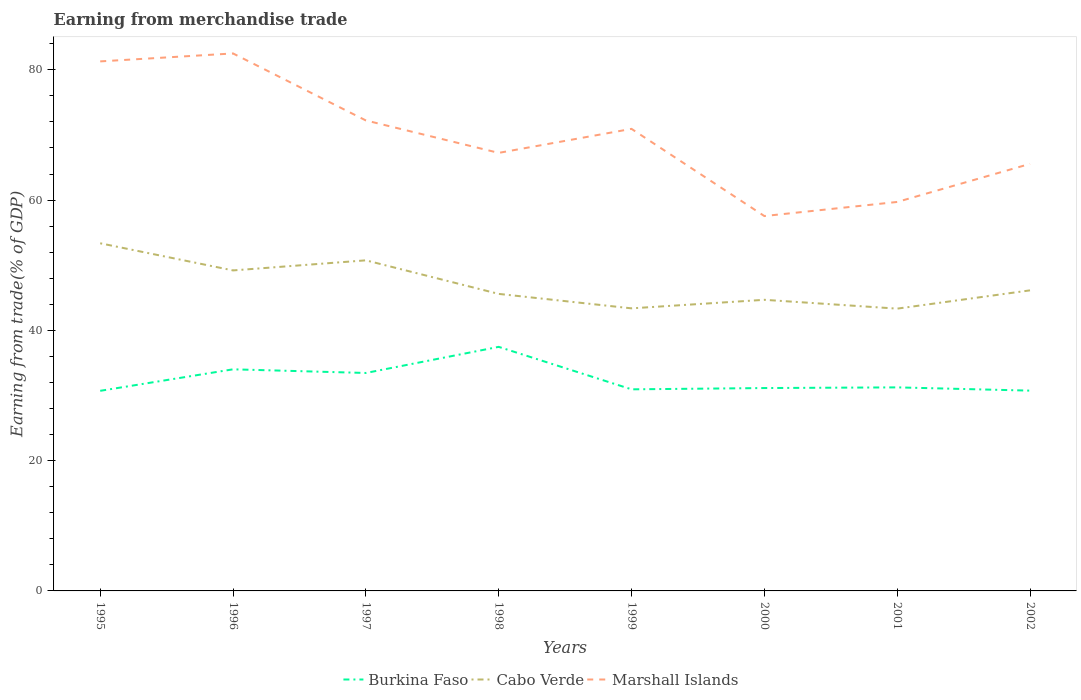Is the number of lines equal to the number of legend labels?
Your response must be concise. Yes. Across all years, what is the maximum earnings from trade in Cabo Verde?
Offer a very short reply. 43.34. In which year was the earnings from trade in Cabo Verde maximum?
Keep it short and to the point. 2001. What is the total earnings from trade in Marshall Islands in the graph?
Keep it short and to the point. 10.29. What is the difference between the highest and the second highest earnings from trade in Cabo Verde?
Your response must be concise. 10.03. What is the difference between the highest and the lowest earnings from trade in Marshall Islands?
Your answer should be compact. 4. Does the graph contain grids?
Ensure brevity in your answer.  No. Where does the legend appear in the graph?
Your answer should be very brief. Bottom center. How are the legend labels stacked?
Provide a succinct answer. Horizontal. What is the title of the graph?
Offer a terse response. Earning from merchandise trade. Does "Kyrgyz Republic" appear as one of the legend labels in the graph?
Your answer should be very brief. No. What is the label or title of the Y-axis?
Offer a terse response. Earning from trade(% of GDP). What is the Earning from trade(% of GDP) of Burkina Faso in 1995?
Keep it short and to the point. 30.72. What is the Earning from trade(% of GDP) in Cabo Verde in 1995?
Give a very brief answer. 53.37. What is the Earning from trade(% of GDP) in Marshall Islands in 1995?
Give a very brief answer. 81.3. What is the Earning from trade(% of GDP) in Burkina Faso in 1996?
Your answer should be very brief. 34.02. What is the Earning from trade(% of GDP) of Cabo Verde in 1996?
Make the answer very short. 49.21. What is the Earning from trade(% of GDP) in Marshall Islands in 1996?
Keep it short and to the point. 82.52. What is the Earning from trade(% of GDP) of Burkina Faso in 1997?
Offer a very short reply. 33.46. What is the Earning from trade(% of GDP) of Cabo Verde in 1997?
Give a very brief answer. 50.75. What is the Earning from trade(% of GDP) in Marshall Islands in 1997?
Provide a succinct answer. 72.23. What is the Earning from trade(% of GDP) in Burkina Faso in 1998?
Offer a very short reply. 37.47. What is the Earning from trade(% of GDP) of Cabo Verde in 1998?
Provide a short and direct response. 45.6. What is the Earning from trade(% of GDP) of Marshall Islands in 1998?
Keep it short and to the point. 67.25. What is the Earning from trade(% of GDP) of Burkina Faso in 1999?
Give a very brief answer. 30.95. What is the Earning from trade(% of GDP) of Cabo Verde in 1999?
Give a very brief answer. 43.38. What is the Earning from trade(% of GDP) of Marshall Islands in 1999?
Provide a succinct answer. 70.94. What is the Earning from trade(% of GDP) in Burkina Faso in 2000?
Give a very brief answer. 31.15. What is the Earning from trade(% of GDP) of Cabo Verde in 2000?
Ensure brevity in your answer.  44.69. What is the Earning from trade(% of GDP) of Marshall Islands in 2000?
Your answer should be compact. 57.55. What is the Earning from trade(% of GDP) in Burkina Faso in 2001?
Keep it short and to the point. 31.25. What is the Earning from trade(% of GDP) in Cabo Verde in 2001?
Ensure brevity in your answer.  43.34. What is the Earning from trade(% of GDP) of Marshall Islands in 2001?
Keep it short and to the point. 59.72. What is the Earning from trade(% of GDP) of Burkina Faso in 2002?
Provide a succinct answer. 30.75. What is the Earning from trade(% of GDP) of Cabo Verde in 2002?
Give a very brief answer. 46.14. What is the Earning from trade(% of GDP) in Marshall Islands in 2002?
Keep it short and to the point. 65.56. Across all years, what is the maximum Earning from trade(% of GDP) of Burkina Faso?
Make the answer very short. 37.47. Across all years, what is the maximum Earning from trade(% of GDP) of Cabo Verde?
Keep it short and to the point. 53.37. Across all years, what is the maximum Earning from trade(% of GDP) of Marshall Islands?
Your answer should be very brief. 82.52. Across all years, what is the minimum Earning from trade(% of GDP) of Burkina Faso?
Keep it short and to the point. 30.72. Across all years, what is the minimum Earning from trade(% of GDP) in Cabo Verde?
Make the answer very short. 43.34. Across all years, what is the minimum Earning from trade(% of GDP) in Marshall Islands?
Offer a very short reply. 57.55. What is the total Earning from trade(% of GDP) in Burkina Faso in the graph?
Keep it short and to the point. 259.77. What is the total Earning from trade(% of GDP) of Cabo Verde in the graph?
Your response must be concise. 376.49. What is the total Earning from trade(% of GDP) in Marshall Islands in the graph?
Offer a very short reply. 557.06. What is the difference between the Earning from trade(% of GDP) in Burkina Faso in 1995 and that in 1996?
Offer a very short reply. -3.3. What is the difference between the Earning from trade(% of GDP) in Cabo Verde in 1995 and that in 1996?
Ensure brevity in your answer.  4.17. What is the difference between the Earning from trade(% of GDP) in Marshall Islands in 1995 and that in 1996?
Your answer should be very brief. -1.22. What is the difference between the Earning from trade(% of GDP) of Burkina Faso in 1995 and that in 1997?
Your answer should be very brief. -2.74. What is the difference between the Earning from trade(% of GDP) of Cabo Verde in 1995 and that in 1997?
Offer a terse response. 2.62. What is the difference between the Earning from trade(% of GDP) of Marshall Islands in 1995 and that in 1997?
Offer a very short reply. 9.07. What is the difference between the Earning from trade(% of GDP) of Burkina Faso in 1995 and that in 1998?
Offer a terse response. -6.75. What is the difference between the Earning from trade(% of GDP) of Cabo Verde in 1995 and that in 1998?
Offer a very short reply. 7.77. What is the difference between the Earning from trade(% of GDP) in Marshall Islands in 1995 and that in 1998?
Give a very brief answer. 14.05. What is the difference between the Earning from trade(% of GDP) of Burkina Faso in 1995 and that in 1999?
Provide a succinct answer. -0.23. What is the difference between the Earning from trade(% of GDP) in Cabo Verde in 1995 and that in 1999?
Provide a short and direct response. 9.99. What is the difference between the Earning from trade(% of GDP) of Marshall Islands in 1995 and that in 1999?
Ensure brevity in your answer.  10.36. What is the difference between the Earning from trade(% of GDP) in Burkina Faso in 1995 and that in 2000?
Offer a very short reply. -0.43. What is the difference between the Earning from trade(% of GDP) of Cabo Verde in 1995 and that in 2000?
Provide a succinct answer. 8.68. What is the difference between the Earning from trade(% of GDP) in Marshall Islands in 1995 and that in 2000?
Your response must be concise. 23.74. What is the difference between the Earning from trade(% of GDP) in Burkina Faso in 1995 and that in 2001?
Your answer should be very brief. -0.53. What is the difference between the Earning from trade(% of GDP) of Cabo Verde in 1995 and that in 2001?
Your answer should be compact. 10.03. What is the difference between the Earning from trade(% of GDP) of Marshall Islands in 1995 and that in 2001?
Offer a very short reply. 21.58. What is the difference between the Earning from trade(% of GDP) of Burkina Faso in 1995 and that in 2002?
Offer a terse response. -0.03. What is the difference between the Earning from trade(% of GDP) in Cabo Verde in 1995 and that in 2002?
Give a very brief answer. 7.23. What is the difference between the Earning from trade(% of GDP) in Marshall Islands in 1995 and that in 2002?
Offer a terse response. 15.73. What is the difference between the Earning from trade(% of GDP) in Burkina Faso in 1996 and that in 1997?
Offer a very short reply. 0.56. What is the difference between the Earning from trade(% of GDP) of Cabo Verde in 1996 and that in 1997?
Your answer should be compact. -1.55. What is the difference between the Earning from trade(% of GDP) of Marshall Islands in 1996 and that in 1997?
Your answer should be very brief. 10.29. What is the difference between the Earning from trade(% of GDP) of Burkina Faso in 1996 and that in 1998?
Your answer should be very brief. -3.45. What is the difference between the Earning from trade(% of GDP) of Cabo Verde in 1996 and that in 1998?
Your answer should be compact. 3.6. What is the difference between the Earning from trade(% of GDP) in Marshall Islands in 1996 and that in 1998?
Make the answer very short. 15.27. What is the difference between the Earning from trade(% of GDP) of Burkina Faso in 1996 and that in 1999?
Ensure brevity in your answer.  3.07. What is the difference between the Earning from trade(% of GDP) of Cabo Verde in 1996 and that in 1999?
Your answer should be compact. 5.82. What is the difference between the Earning from trade(% of GDP) of Marshall Islands in 1996 and that in 1999?
Ensure brevity in your answer.  11.58. What is the difference between the Earning from trade(% of GDP) of Burkina Faso in 1996 and that in 2000?
Give a very brief answer. 2.88. What is the difference between the Earning from trade(% of GDP) of Cabo Verde in 1996 and that in 2000?
Provide a short and direct response. 4.51. What is the difference between the Earning from trade(% of GDP) of Marshall Islands in 1996 and that in 2000?
Offer a very short reply. 24.96. What is the difference between the Earning from trade(% of GDP) in Burkina Faso in 1996 and that in 2001?
Give a very brief answer. 2.77. What is the difference between the Earning from trade(% of GDP) of Cabo Verde in 1996 and that in 2001?
Ensure brevity in your answer.  5.87. What is the difference between the Earning from trade(% of GDP) of Marshall Islands in 1996 and that in 2001?
Offer a very short reply. 22.8. What is the difference between the Earning from trade(% of GDP) of Burkina Faso in 1996 and that in 2002?
Offer a terse response. 3.27. What is the difference between the Earning from trade(% of GDP) of Cabo Verde in 1996 and that in 2002?
Offer a very short reply. 3.06. What is the difference between the Earning from trade(% of GDP) of Marshall Islands in 1996 and that in 2002?
Give a very brief answer. 16.95. What is the difference between the Earning from trade(% of GDP) in Burkina Faso in 1997 and that in 1998?
Keep it short and to the point. -4.01. What is the difference between the Earning from trade(% of GDP) of Cabo Verde in 1997 and that in 1998?
Your answer should be compact. 5.15. What is the difference between the Earning from trade(% of GDP) in Marshall Islands in 1997 and that in 1998?
Make the answer very short. 4.98. What is the difference between the Earning from trade(% of GDP) in Burkina Faso in 1997 and that in 1999?
Make the answer very short. 2.51. What is the difference between the Earning from trade(% of GDP) in Cabo Verde in 1997 and that in 1999?
Give a very brief answer. 7.37. What is the difference between the Earning from trade(% of GDP) of Marshall Islands in 1997 and that in 1999?
Offer a terse response. 1.29. What is the difference between the Earning from trade(% of GDP) of Burkina Faso in 1997 and that in 2000?
Make the answer very short. 2.31. What is the difference between the Earning from trade(% of GDP) of Cabo Verde in 1997 and that in 2000?
Keep it short and to the point. 6.06. What is the difference between the Earning from trade(% of GDP) in Marshall Islands in 1997 and that in 2000?
Your answer should be very brief. 14.68. What is the difference between the Earning from trade(% of GDP) in Burkina Faso in 1997 and that in 2001?
Keep it short and to the point. 2.21. What is the difference between the Earning from trade(% of GDP) in Cabo Verde in 1997 and that in 2001?
Your answer should be very brief. 7.42. What is the difference between the Earning from trade(% of GDP) in Marshall Islands in 1997 and that in 2001?
Offer a very short reply. 12.51. What is the difference between the Earning from trade(% of GDP) of Burkina Faso in 1997 and that in 2002?
Offer a terse response. 2.71. What is the difference between the Earning from trade(% of GDP) in Cabo Verde in 1997 and that in 2002?
Your answer should be very brief. 4.61. What is the difference between the Earning from trade(% of GDP) in Marshall Islands in 1997 and that in 2002?
Offer a very short reply. 6.66. What is the difference between the Earning from trade(% of GDP) in Burkina Faso in 1998 and that in 1999?
Your answer should be very brief. 6.52. What is the difference between the Earning from trade(% of GDP) in Cabo Verde in 1998 and that in 1999?
Your answer should be very brief. 2.22. What is the difference between the Earning from trade(% of GDP) of Marshall Islands in 1998 and that in 1999?
Keep it short and to the point. -3.69. What is the difference between the Earning from trade(% of GDP) in Burkina Faso in 1998 and that in 2000?
Your response must be concise. 6.32. What is the difference between the Earning from trade(% of GDP) in Cabo Verde in 1998 and that in 2000?
Ensure brevity in your answer.  0.91. What is the difference between the Earning from trade(% of GDP) in Marshall Islands in 1998 and that in 2000?
Your answer should be very brief. 9.7. What is the difference between the Earning from trade(% of GDP) of Burkina Faso in 1998 and that in 2001?
Keep it short and to the point. 6.22. What is the difference between the Earning from trade(% of GDP) in Cabo Verde in 1998 and that in 2001?
Your answer should be very brief. 2.26. What is the difference between the Earning from trade(% of GDP) in Marshall Islands in 1998 and that in 2001?
Offer a very short reply. 7.53. What is the difference between the Earning from trade(% of GDP) of Burkina Faso in 1998 and that in 2002?
Your answer should be very brief. 6.72. What is the difference between the Earning from trade(% of GDP) of Cabo Verde in 1998 and that in 2002?
Your answer should be very brief. -0.54. What is the difference between the Earning from trade(% of GDP) of Marshall Islands in 1998 and that in 2002?
Ensure brevity in your answer.  1.69. What is the difference between the Earning from trade(% of GDP) in Burkina Faso in 1999 and that in 2000?
Your answer should be compact. -0.2. What is the difference between the Earning from trade(% of GDP) in Cabo Verde in 1999 and that in 2000?
Ensure brevity in your answer.  -1.31. What is the difference between the Earning from trade(% of GDP) of Marshall Islands in 1999 and that in 2000?
Give a very brief answer. 13.38. What is the difference between the Earning from trade(% of GDP) of Burkina Faso in 1999 and that in 2001?
Offer a very short reply. -0.3. What is the difference between the Earning from trade(% of GDP) of Cabo Verde in 1999 and that in 2001?
Your answer should be very brief. 0.04. What is the difference between the Earning from trade(% of GDP) in Marshall Islands in 1999 and that in 2001?
Give a very brief answer. 11.22. What is the difference between the Earning from trade(% of GDP) in Burkina Faso in 1999 and that in 2002?
Offer a terse response. 0.2. What is the difference between the Earning from trade(% of GDP) in Cabo Verde in 1999 and that in 2002?
Your response must be concise. -2.76. What is the difference between the Earning from trade(% of GDP) of Marshall Islands in 1999 and that in 2002?
Your response must be concise. 5.37. What is the difference between the Earning from trade(% of GDP) of Burkina Faso in 2000 and that in 2001?
Offer a terse response. -0.1. What is the difference between the Earning from trade(% of GDP) of Cabo Verde in 2000 and that in 2001?
Offer a terse response. 1.36. What is the difference between the Earning from trade(% of GDP) of Marshall Islands in 2000 and that in 2001?
Make the answer very short. -2.16. What is the difference between the Earning from trade(% of GDP) of Burkina Faso in 2000 and that in 2002?
Keep it short and to the point. 0.4. What is the difference between the Earning from trade(% of GDP) of Cabo Verde in 2000 and that in 2002?
Give a very brief answer. -1.45. What is the difference between the Earning from trade(% of GDP) in Marshall Islands in 2000 and that in 2002?
Keep it short and to the point. -8.01. What is the difference between the Earning from trade(% of GDP) of Burkina Faso in 2001 and that in 2002?
Provide a succinct answer. 0.5. What is the difference between the Earning from trade(% of GDP) in Cabo Verde in 2001 and that in 2002?
Give a very brief answer. -2.81. What is the difference between the Earning from trade(% of GDP) in Marshall Islands in 2001 and that in 2002?
Your answer should be compact. -5.85. What is the difference between the Earning from trade(% of GDP) of Burkina Faso in 1995 and the Earning from trade(% of GDP) of Cabo Verde in 1996?
Provide a short and direct response. -18.48. What is the difference between the Earning from trade(% of GDP) of Burkina Faso in 1995 and the Earning from trade(% of GDP) of Marshall Islands in 1996?
Your response must be concise. -51.8. What is the difference between the Earning from trade(% of GDP) of Cabo Verde in 1995 and the Earning from trade(% of GDP) of Marshall Islands in 1996?
Offer a terse response. -29.14. What is the difference between the Earning from trade(% of GDP) in Burkina Faso in 1995 and the Earning from trade(% of GDP) in Cabo Verde in 1997?
Give a very brief answer. -20.03. What is the difference between the Earning from trade(% of GDP) in Burkina Faso in 1995 and the Earning from trade(% of GDP) in Marshall Islands in 1997?
Make the answer very short. -41.51. What is the difference between the Earning from trade(% of GDP) in Cabo Verde in 1995 and the Earning from trade(% of GDP) in Marshall Islands in 1997?
Your answer should be compact. -18.86. What is the difference between the Earning from trade(% of GDP) of Burkina Faso in 1995 and the Earning from trade(% of GDP) of Cabo Verde in 1998?
Give a very brief answer. -14.88. What is the difference between the Earning from trade(% of GDP) in Burkina Faso in 1995 and the Earning from trade(% of GDP) in Marshall Islands in 1998?
Provide a short and direct response. -36.53. What is the difference between the Earning from trade(% of GDP) of Cabo Verde in 1995 and the Earning from trade(% of GDP) of Marshall Islands in 1998?
Your answer should be very brief. -13.88. What is the difference between the Earning from trade(% of GDP) of Burkina Faso in 1995 and the Earning from trade(% of GDP) of Cabo Verde in 1999?
Offer a terse response. -12.66. What is the difference between the Earning from trade(% of GDP) of Burkina Faso in 1995 and the Earning from trade(% of GDP) of Marshall Islands in 1999?
Offer a terse response. -40.22. What is the difference between the Earning from trade(% of GDP) of Cabo Verde in 1995 and the Earning from trade(% of GDP) of Marshall Islands in 1999?
Offer a terse response. -17.57. What is the difference between the Earning from trade(% of GDP) of Burkina Faso in 1995 and the Earning from trade(% of GDP) of Cabo Verde in 2000?
Keep it short and to the point. -13.97. What is the difference between the Earning from trade(% of GDP) of Burkina Faso in 1995 and the Earning from trade(% of GDP) of Marshall Islands in 2000?
Provide a short and direct response. -26.83. What is the difference between the Earning from trade(% of GDP) in Cabo Verde in 1995 and the Earning from trade(% of GDP) in Marshall Islands in 2000?
Provide a succinct answer. -4.18. What is the difference between the Earning from trade(% of GDP) in Burkina Faso in 1995 and the Earning from trade(% of GDP) in Cabo Verde in 2001?
Give a very brief answer. -12.62. What is the difference between the Earning from trade(% of GDP) of Burkina Faso in 1995 and the Earning from trade(% of GDP) of Marshall Islands in 2001?
Provide a short and direct response. -29. What is the difference between the Earning from trade(% of GDP) of Cabo Verde in 1995 and the Earning from trade(% of GDP) of Marshall Islands in 2001?
Offer a terse response. -6.34. What is the difference between the Earning from trade(% of GDP) in Burkina Faso in 1995 and the Earning from trade(% of GDP) in Cabo Verde in 2002?
Ensure brevity in your answer.  -15.42. What is the difference between the Earning from trade(% of GDP) of Burkina Faso in 1995 and the Earning from trade(% of GDP) of Marshall Islands in 2002?
Ensure brevity in your answer.  -34.84. What is the difference between the Earning from trade(% of GDP) in Cabo Verde in 1995 and the Earning from trade(% of GDP) in Marshall Islands in 2002?
Give a very brief answer. -12.19. What is the difference between the Earning from trade(% of GDP) in Burkina Faso in 1996 and the Earning from trade(% of GDP) in Cabo Verde in 1997?
Offer a terse response. -16.73. What is the difference between the Earning from trade(% of GDP) of Burkina Faso in 1996 and the Earning from trade(% of GDP) of Marshall Islands in 1997?
Ensure brevity in your answer.  -38.21. What is the difference between the Earning from trade(% of GDP) of Cabo Verde in 1996 and the Earning from trade(% of GDP) of Marshall Islands in 1997?
Your answer should be compact. -23.02. What is the difference between the Earning from trade(% of GDP) of Burkina Faso in 1996 and the Earning from trade(% of GDP) of Cabo Verde in 1998?
Your response must be concise. -11.58. What is the difference between the Earning from trade(% of GDP) of Burkina Faso in 1996 and the Earning from trade(% of GDP) of Marshall Islands in 1998?
Provide a short and direct response. -33.23. What is the difference between the Earning from trade(% of GDP) of Cabo Verde in 1996 and the Earning from trade(% of GDP) of Marshall Islands in 1998?
Offer a very short reply. -18.05. What is the difference between the Earning from trade(% of GDP) of Burkina Faso in 1996 and the Earning from trade(% of GDP) of Cabo Verde in 1999?
Your answer should be very brief. -9.36. What is the difference between the Earning from trade(% of GDP) of Burkina Faso in 1996 and the Earning from trade(% of GDP) of Marshall Islands in 1999?
Make the answer very short. -36.91. What is the difference between the Earning from trade(% of GDP) of Cabo Verde in 1996 and the Earning from trade(% of GDP) of Marshall Islands in 1999?
Ensure brevity in your answer.  -21.73. What is the difference between the Earning from trade(% of GDP) of Burkina Faso in 1996 and the Earning from trade(% of GDP) of Cabo Verde in 2000?
Your response must be concise. -10.67. What is the difference between the Earning from trade(% of GDP) in Burkina Faso in 1996 and the Earning from trade(% of GDP) in Marshall Islands in 2000?
Keep it short and to the point. -23.53. What is the difference between the Earning from trade(% of GDP) of Cabo Verde in 1996 and the Earning from trade(% of GDP) of Marshall Islands in 2000?
Make the answer very short. -8.35. What is the difference between the Earning from trade(% of GDP) in Burkina Faso in 1996 and the Earning from trade(% of GDP) in Cabo Verde in 2001?
Your response must be concise. -9.32. What is the difference between the Earning from trade(% of GDP) in Burkina Faso in 1996 and the Earning from trade(% of GDP) in Marshall Islands in 2001?
Offer a terse response. -25.69. What is the difference between the Earning from trade(% of GDP) of Cabo Verde in 1996 and the Earning from trade(% of GDP) of Marshall Islands in 2001?
Offer a terse response. -10.51. What is the difference between the Earning from trade(% of GDP) in Burkina Faso in 1996 and the Earning from trade(% of GDP) in Cabo Verde in 2002?
Offer a terse response. -12.12. What is the difference between the Earning from trade(% of GDP) of Burkina Faso in 1996 and the Earning from trade(% of GDP) of Marshall Islands in 2002?
Offer a terse response. -31.54. What is the difference between the Earning from trade(% of GDP) of Cabo Verde in 1996 and the Earning from trade(% of GDP) of Marshall Islands in 2002?
Your response must be concise. -16.36. What is the difference between the Earning from trade(% of GDP) in Burkina Faso in 1997 and the Earning from trade(% of GDP) in Cabo Verde in 1998?
Your response must be concise. -12.14. What is the difference between the Earning from trade(% of GDP) of Burkina Faso in 1997 and the Earning from trade(% of GDP) of Marshall Islands in 1998?
Give a very brief answer. -33.79. What is the difference between the Earning from trade(% of GDP) in Cabo Verde in 1997 and the Earning from trade(% of GDP) in Marshall Islands in 1998?
Provide a succinct answer. -16.5. What is the difference between the Earning from trade(% of GDP) of Burkina Faso in 1997 and the Earning from trade(% of GDP) of Cabo Verde in 1999?
Offer a very short reply. -9.92. What is the difference between the Earning from trade(% of GDP) of Burkina Faso in 1997 and the Earning from trade(% of GDP) of Marshall Islands in 1999?
Your answer should be compact. -37.48. What is the difference between the Earning from trade(% of GDP) in Cabo Verde in 1997 and the Earning from trade(% of GDP) in Marshall Islands in 1999?
Keep it short and to the point. -20.18. What is the difference between the Earning from trade(% of GDP) of Burkina Faso in 1997 and the Earning from trade(% of GDP) of Cabo Verde in 2000?
Your answer should be very brief. -11.23. What is the difference between the Earning from trade(% of GDP) in Burkina Faso in 1997 and the Earning from trade(% of GDP) in Marshall Islands in 2000?
Provide a short and direct response. -24.09. What is the difference between the Earning from trade(% of GDP) of Cabo Verde in 1997 and the Earning from trade(% of GDP) of Marshall Islands in 2000?
Your answer should be compact. -6.8. What is the difference between the Earning from trade(% of GDP) of Burkina Faso in 1997 and the Earning from trade(% of GDP) of Cabo Verde in 2001?
Ensure brevity in your answer.  -9.88. What is the difference between the Earning from trade(% of GDP) in Burkina Faso in 1997 and the Earning from trade(% of GDP) in Marshall Islands in 2001?
Make the answer very short. -26.26. What is the difference between the Earning from trade(% of GDP) of Cabo Verde in 1997 and the Earning from trade(% of GDP) of Marshall Islands in 2001?
Ensure brevity in your answer.  -8.96. What is the difference between the Earning from trade(% of GDP) of Burkina Faso in 1997 and the Earning from trade(% of GDP) of Cabo Verde in 2002?
Make the answer very short. -12.68. What is the difference between the Earning from trade(% of GDP) in Burkina Faso in 1997 and the Earning from trade(% of GDP) in Marshall Islands in 2002?
Provide a short and direct response. -32.1. What is the difference between the Earning from trade(% of GDP) in Cabo Verde in 1997 and the Earning from trade(% of GDP) in Marshall Islands in 2002?
Give a very brief answer. -14.81. What is the difference between the Earning from trade(% of GDP) in Burkina Faso in 1998 and the Earning from trade(% of GDP) in Cabo Verde in 1999?
Provide a short and direct response. -5.91. What is the difference between the Earning from trade(% of GDP) in Burkina Faso in 1998 and the Earning from trade(% of GDP) in Marshall Islands in 1999?
Offer a very short reply. -33.47. What is the difference between the Earning from trade(% of GDP) in Cabo Verde in 1998 and the Earning from trade(% of GDP) in Marshall Islands in 1999?
Give a very brief answer. -25.34. What is the difference between the Earning from trade(% of GDP) of Burkina Faso in 1998 and the Earning from trade(% of GDP) of Cabo Verde in 2000?
Ensure brevity in your answer.  -7.22. What is the difference between the Earning from trade(% of GDP) of Burkina Faso in 1998 and the Earning from trade(% of GDP) of Marshall Islands in 2000?
Your answer should be very brief. -20.08. What is the difference between the Earning from trade(% of GDP) of Cabo Verde in 1998 and the Earning from trade(% of GDP) of Marshall Islands in 2000?
Your answer should be very brief. -11.95. What is the difference between the Earning from trade(% of GDP) of Burkina Faso in 1998 and the Earning from trade(% of GDP) of Cabo Verde in 2001?
Give a very brief answer. -5.87. What is the difference between the Earning from trade(% of GDP) of Burkina Faso in 1998 and the Earning from trade(% of GDP) of Marshall Islands in 2001?
Provide a succinct answer. -22.25. What is the difference between the Earning from trade(% of GDP) of Cabo Verde in 1998 and the Earning from trade(% of GDP) of Marshall Islands in 2001?
Offer a very short reply. -14.12. What is the difference between the Earning from trade(% of GDP) in Burkina Faso in 1998 and the Earning from trade(% of GDP) in Cabo Verde in 2002?
Offer a very short reply. -8.67. What is the difference between the Earning from trade(% of GDP) in Burkina Faso in 1998 and the Earning from trade(% of GDP) in Marshall Islands in 2002?
Keep it short and to the point. -28.09. What is the difference between the Earning from trade(% of GDP) in Cabo Verde in 1998 and the Earning from trade(% of GDP) in Marshall Islands in 2002?
Give a very brief answer. -19.96. What is the difference between the Earning from trade(% of GDP) in Burkina Faso in 1999 and the Earning from trade(% of GDP) in Cabo Verde in 2000?
Offer a terse response. -13.74. What is the difference between the Earning from trade(% of GDP) of Burkina Faso in 1999 and the Earning from trade(% of GDP) of Marshall Islands in 2000?
Ensure brevity in your answer.  -26.6. What is the difference between the Earning from trade(% of GDP) of Cabo Verde in 1999 and the Earning from trade(% of GDP) of Marshall Islands in 2000?
Offer a very short reply. -14.17. What is the difference between the Earning from trade(% of GDP) in Burkina Faso in 1999 and the Earning from trade(% of GDP) in Cabo Verde in 2001?
Your answer should be compact. -12.39. What is the difference between the Earning from trade(% of GDP) of Burkina Faso in 1999 and the Earning from trade(% of GDP) of Marshall Islands in 2001?
Offer a terse response. -28.77. What is the difference between the Earning from trade(% of GDP) of Cabo Verde in 1999 and the Earning from trade(% of GDP) of Marshall Islands in 2001?
Give a very brief answer. -16.34. What is the difference between the Earning from trade(% of GDP) of Burkina Faso in 1999 and the Earning from trade(% of GDP) of Cabo Verde in 2002?
Your response must be concise. -15.19. What is the difference between the Earning from trade(% of GDP) of Burkina Faso in 1999 and the Earning from trade(% of GDP) of Marshall Islands in 2002?
Offer a terse response. -34.62. What is the difference between the Earning from trade(% of GDP) of Cabo Verde in 1999 and the Earning from trade(% of GDP) of Marshall Islands in 2002?
Your response must be concise. -22.18. What is the difference between the Earning from trade(% of GDP) in Burkina Faso in 2000 and the Earning from trade(% of GDP) in Cabo Verde in 2001?
Provide a short and direct response. -12.19. What is the difference between the Earning from trade(% of GDP) in Burkina Faso in 2000 and the Earning from trade(% of GDP) in Marshall Islands in 2001?
Your answer should be compact. -28.57. What is the difference between the Earning from trade(% of GDP) in Cabo Verde in 2000 and the Earning from trade(% of GDP) in Marshall Islands in 2001?
Provide a short and direct response. -15.02. What is the difference between the Earning from trade(% of GDP) in Burkina Faso in 2000 and the Earning from trade(% of GDP) in Cabo Verde in 2002?
Provide a succinct answer. -15. What is the difference between the Earning from trade(% of GDP) in Burkina Faso in 2000 and the Earning from trade(% of GDP) in Marshall Islands in 2002?
Ensure brevity in your answer.  -34.42. What is the difference between the Earning from trade(% of GDP) of Cabo Verde in 2000 and the Earning from trade(% of GDP) of Marshall Islands in 2002?
Ensure brevity in your answer.  -20.87. What is the difference between the Earning from trade(% of GDP) in Burkina Faso in 2001 and the Earning from trade(% of GDP) in Cabo Verde in 2002?
Keep it short and to the point. -14.89. What is the difference between the Earning from trade(% of GDP) of Burkina Faso in 2001 and the Earning from trade(% of GDP) of Marshall Islands in 2002?
Ensure brevity in your answer.  -34.32. What is the difference between the Earning from trade(% of GDP) in Cabo Verde in 2001 and the Earning from trade(% of GDP) in Marshall Islands in 2002?
Your answer should be very brief. -22.23. What is the average Earning from trade(% of GDP) of Burkina Faso per year?
Offer a very short reply. 32.47. What is the average Earning from trade(% of GDP) in Cabo Verde per year?
Provide a succinct answer. 47.06. What is the average Earning from trade(% of GDP) of Marshall Islands per year?
Keep it short and to the point. 69.63. In the year 1995, what is the difference between the Earning from trade(% of GDP) in Burkina Faso and Earning from trade(% of GDP) in Cabo Verde?
Keep it short and to the point. -22.65. In the year 1995, what is the difference between the Earning from trade(% of GDP) of Burkina Faso and Earning from trade(% of GDP) of Marshall Islands?
Keep it short and to the point. -50.58. In the year 1995, what is the difference between the Earning from trade(% of GDP) of Cabo Verde and Earning from trade(% of GDP) of Marshall Islands?
Ensure brevity in your answer.  -27.92. In the year 1996, what is the difference between the Earning from trade(% of GDP) in Burkina Faso and Earning from trade(% of GDP) in Cabo Verde?
Make the answer very short. -15.18. In the year 1996, what is the difference between the Earning from trade(% of GDP) in Burkina Faso and Earning from trade(% of GDP) in Marshall Islands?
Ensure brevity in your answer.  -48.49. In the year 1996, what is the difference between the Earning from trade(% of GDP) in Cabo Verde and Earning from trade(% of GDP) in Marshall Islands?
Provide a short and direct response. -33.31. In the year 1997, what is the difference between the Earning from trade(% of GDP) in Burkina Faso and Earning from trade(% of GDP) in Cabo Verde?
Your answer should be compact. -17.29. In the year 1997, what is the difference between the Earning from trade(% of GDP) of Burkina Faso and Earning from trade(% of GDP) of Marshall Islands?
Keep it short and to the point. -38.77. In the year 1997, what is the difference between the Earning from trade(% of GDP) of Cabo Verde and Earning from trade(% of GDP) of Marshall Islands?
Make the answer very short. -21.48. In the year 1998, what is the difference between the Earning from trade(% of GDP) in Burkina Faso and Earning from trade(% of GDP) in Cabo Verde?
Keep it short and to the point. -8.13. In the year 1998, what is the difference between the Earning from trade(% of GDP) of Burkina Faso and Earning from trade(% of GDP) of Marshall Islands?
Make the answer very short. -29.78. In the year 1998, what is the difference between the Earning from trade(% of GDP) of Cabo Verde and Earning from trade(% of GDP) of Marshall Islands?
Provide a short and direct response. -21.65. In the year 1999, what is the difference between the Earning from trade(% of GDP) of Burkina Faso and Earning from trade(% of GDP) of Cabo Verde?
Offer a terse response. -12.43. In the year 1999, what is the difference between the Earning from trade(% of GDP) of Burkina Faso and Earning from trade(% of GDP) of Marshall Islands?
Your answer should be compact. -39.99. In the year 1999, what is the difference between the Earning from trade(% of GDP) in Cabo Verde and Earning from trade(% of GDP) in Marshall Islands?
Keep it short and to the point. -27.56. In the year 2000, what is the difference between the Earning from trade(% of GDP) of Burkina Faso and Earning from trade(% of GDP) of Cabo Verde?
Offer a very short reply. -13.55. In the year 2000, what is the difference between the Earning from trade(% of GDP) of Burkina Faso and Earning from trade(% of GDP) of Marshall Islands?
Your answer should be very brief. -26.41. In the year 2000, what is the difference between the Earning from trade(% of GDP) of Cabo Verde and Earning from trade(% of GDP) of Marshall Islands?
Your response must be concise. -12.86. In the year 2001, what is the difference between the Earning from trade(% of GDP) in Burkina Faso and Earning from trade(% of GDP) in Cabo Verde?
Offer a terse response. -12.09. In the year 2001, what is the difference between the Earning from trade(% of GDP) of Burkina Faso and Earning from trade(% of GDP) of Marshall Islands?
Provide a succinct answer. -28.47. In the year 2001, what is the difference between the Earning from trade(% of GDP) in Cabo Verde and Earning from trade(% of GDP) in Marshall Islands?
Your answer should be very brief. -16.38. In the year 2002, what is the difference between the Earning from trade(% of GDP) in Burkina Faso and Earning from trade(% of GDP) in Cabo Verde?
Your answer should be very brief. -15.39. In the year 2002, what is the difference between the Earning from trade(% of GDP) of Burkina Faso and Earning from trade(% of GDP) of Marshall Islands?
Provide a short and direct response. -34.81. In the year 2002, what is the difference between the Earning from trade(% of GDP) of Cabo Verde and Earning from trade(% of GDP) of Marshall Islands?
Provide a succinct answer. -19.42. What is the ratio of the Earning from trade(% of GDP) in Burkina Faso in 1995 to that in 1996?
Make the answer very short. 0.9. What is the ratio of the Earning from trade(% of GDP) in Cabo Verde in 1995 to that in 1996?
Keep it short and to the point. 1.08. What is the ratio of the Earning from trade(% of GDP) in Marshall Islands in 1995 to that in 1996?
Provide a succinct answer. 0.99. What is the ratio of the Earning from trade(% of GDP) of Burkina Faso in 1995 to that in 1997?
Make the answer very short. 0.92. What is the ratio of the Earning from trade(% of GDP) of Cabo Verde in 1995 to that in 1997?
Your answer should be compact. 1.05. What is the ratio of the Earning from trade(% of GDP) in Marshall Islands in 1995 to that in 1997?
Ensure brevity in your answer.  1.13. What is the ratio of the Earning from trade(% of GDP) in Burkina Faso in 1995 to that in 1998?
Offer a terse response. 0.82. What is the ratio of the Earning from trade(% of GDP) of Cabo Verde in 1995 to that in 1998?
Offer a terse response. 1.17. What is the ratio of the Earning from trade(% of GDP) of Marshall Islands in 1995 to that in 1998?
Your response must be concise. 1.21. What is the ratio of the Earning from trade(% of GDP) of Cabo Verde in 1995 to that in 1999?
Give a very brief answer. 1.23. What is the ratio of the Earning from trade(% of GDP) in Marshall Islands in 1995 to that in 1999?
Your answer should be very brief. 1.15. What is the ratio of the Earning from trade(% of GDP) of Burkina Faso in 1995 to that in 2000?
Make the answer very short. 0.99. What is the ratio of the Earning from trade(% of GDP) of Cabo Verde in 1995 to that in 2000?
Provide a succinct answer. 1.19. What is the ratio of the Earning from trade(% of GDP) in Marshall Islands in 1995 to that in 2000?
Provide a succinct answer. 1.41. What is the ratio of the Earning from trade(% of GDP) of Burkina Faso in 1995 to that in 2001?
Provide a short and direct response. 0.98. What is the ratio of the Earning from trade(% of GDP) in Cabo Verde in 1995 to that in 2001?
Make the answer very short. 1.23. What is the ratio of the Earning from trade(% of GDP) of Marshall Islands in 1995 to that in 2001?
Provide a succinct answer. 1.36. What is the ratio of the Earning from trade(% of GDP) in Cabo Verde in 1995 to that in 2002?
Your answer should be compact. 1.16. What is the ratio of the Earning from trade(% of GDP) of Marshall Islands in 1995 to that in 2002?
Your response must be concise. 1.24. What is the ratio of the Earning from trade(% of GDP) in Burkina Faso in 1996 to that in 1997?
Your response must be concise. 1.02. What is the ratio of the Earning from trade(% of GDP) in Cabo Verde in 1996 to that in 1997?
Provide a short and direct response. 0.97. What is the ratio of the Earning from trade(% of GDP) of Marshall Islands in 1996 to that in 1997?
Keep it short and to the point. 1.14. What is the ratio of the Earning from trade(% of GDP) in Burkina Faso in 1996 to that in 1998?
Give a very brief answer. 0.91. What is the ratio of the Earning from trade(% of GDP) of Cabo Verde in 1996 to that in 1998?
Your answer should be very brief. 1.08. What is the ratio of the Earning from trade(% of GDP) in Marshall Islands in 1996 to that in 1998?
Provide a succinct answer. 1.23. What is the ratio of the Earning from trade(% of GDP) in Burkina Faso in 1996 to that in 1999?
Keep it short and to the point. 1.1. What is the ratio of the Earning from trade(% of GDP) in Cabo Verde in 1996 to that in 1999?
Keep it short and to the point. 1.13. What is the ratio of the Earning from trade(% of GDP) in Marshall Islands in 1996 to that in 1999?
Your answer should be compact. 1.16. What is the ratio of the Earning from trade(% of GDP) in Burkina Faso in 1996 to that in 2000?
Offer a terse response. 1.09. What is the ratio of the Earning from trade(% of GDP) in Cabo Verde in 1996 to that in 2000?
Your answer should be compact. 1.1. What is the ratio of the Earning from trade(% of GDP) of Marshall Islands in 1996 to that in 2000?
Offer a terse response. 1.43. What is the ratio of the Earning from trade(% of GDP) in Burkina Faso in 1996 to that in 2001?
Ensure brevity in your answer.  1.09. What is the ratio of the Earning from trade(% of GDP) in Cabo Verde in 1996 to that in 2001?
Provide a short and direct response. 1.14. What is the ratio of the Earning from trade(% of GDP) in Marshall Islands in 1996 to that in 2001?
Provide a short and direct response. 1.38. What is the ratio of the Earning from trade(% of GDP) in Burkina Faso in 1996 to that in 2002?
Provide a succinct answer. 1.11. What is the ratio of the Earning from trade(% of GDP) of Cabo Verde in 1996 to that in 2002?
Keep it short and to the point. 1.07. What is the ratio of the Earning from trade(% of GDP) of Marshall Islands in 1996 to that in 2002?
Give a very brief answer. 1.26. What is the ratio of the Earning from trade(% of GDP) of Burkina Faso in 1997 to that in 1998?
Give a very brief answer. 0.89. What is the ratio of the Earning from trade(% of GDP) of Cabo Verde in 1997 to that in 1998?
Give a very brief answer. 1.11. What is the ratio of the Earning from trade(% of GDP) in Marshall Islands in 1997 to that in 1998?
Offer a very short reply. 1.07. What is the ratio of the Earning from trade(% of GDP) of Burkina Faso in 1997 to that in 1999?
Give a very brief answer. 1.08. What is the ratio of the Earning from trade(% of GDP) in Cabo Verde in 1997 to that in 1999?
Keep it short and to the point. 1.17. What is the ratio of the Earning from trade(% of GDP) in Marshall Islands in 1997 to that in 1999?
Offer a terse response. 1.02. What is the ratio of the Earning from trade(% of GDP) in Burkina Faso in 1997 to that in 2000?
Offer a very short reply. 1.07. What is the ratio of the Earning from trade(% of GDP) in Cabo Verde in 1997 to that in 2000?
Your answer should be very brief. 1.14. What is the ratio of the Earning from trade(% of GDP) in Marshall Islands in 1997 to that in 2000?
Keep it short and to the point. 1.25. What is the ratio of the Earning from trade(% of GDP) of Burkina Faso in 1997 to that in 2001?
Provide a succinct answer. 1.07. What is the ratio of the Earning from trade(% of GDP) of Cabo Verde in 1997 to that in 2001?
Your response must be concise. 1.17. What is the ratio of the Earning from trade(% of GDP) of Marshall Islands in 1997 to that in 2001?
Provide a short and direct response. 1.21. What is the ratio of the Earning from trade(% of GDP) in Burkina Faso in 1997 to that in 2002?
Offer a very short reply. 1.09. What is the ratio of the Earning from trade(% of GDP) in Cabo Verde in 1997 to that in 2002?
Offer a very short reply. 1.1. What is the ratio of the Earning from trade(% of GDP) of Marshall Islands in 1997 to that in 2002?
Ensure brevity in your answer.  1.1. What is the ratio of the Earning from trade(% of GDP) of Burkina Faso in 1998 to that in 1999?
Your response must be concise. 1.21. What is the ratio of the Earning from trade(% of GDP) of Cabo Verde in 1998 to that in 1999?
Keep it short and to the point. 1.05. What is the ratio of the Earning from trade(% of GDP) of Marshall Islands in 1998 to that in 1999?
Ensure brevity in your answer.  0.95. What is the ratio of the Earning from trade(% of GDP) in Burkina Faso in 1998 to that in 2000?
Your answer should be compact. 1.2. What is the ratio of the Earning from trade(% of GDP) of Cabo Verde in 1998 to that in 2000?
Give a very brief answer. 1.02. What is the ratio of the Earning from trade(% of GDP) of Marshall Islands in 1998 to that in 2000?
Keep it short and to the point. 1.17. What is the ratio of the Earning from trade(% of GDP) in Burkina Faso in 1998 to that in 2001?
Your answer should be very brief. 1.2. What is the ratio of the Earning from trade(% of GDP) of Cabo Verde in 1998 to that in 2001?
Keep it short and to the point. 1.05. What is the ratio of the Earning from trade(% of GDP) of Marshall Islands in 1998 to that in 2001?
Provide a short and direct response. 1.13. What is the ratio of the Earning from trade(% of GDP) in Burkina Faso in 1998 to that in 2002?
Offer a terse response. 1.22. What is the ratio of the Earning from trade(% of GDP) in Cabo Verde in 1998 to that in 2002?
Offer a very short reply. 0.99. What is the ratio of the Earning from trade(% of GDP) in Marshall Islands in 1998 to that in 2002?
Ensure brevity in your answer.  1.03. What is the ratio of the Earning from trade(% of GDP) of Cabo Verde in 1999 to that in 2000?
Provide a succinct answer. 0.97. What is the ratio of the Earning from trade(% of GDP) of Marshall Islands in 1999 to that in 2000?
Offer a terse response. 1.23. What is the ratio of the Earning from trade(% of GDP) in Burkina Faso in 1999 to that in 2001?
Your answer should be compact. 0.99. What is the ratio of the Earning from trade(% of GDP) of Marshall Islands in 1999 to that in 2001?
Your response must be concise. 1.19. What is the ratio of the Earning from trade(% of GDP) in Burkina Faso in 1999 to that in 2002?
Offer a very short reply. 1.01. What is the ratio of the Earning from trade(% of GDP) in Cabo Verde in 1999 to that in 2002?
Your response must be concise. 0.94. What is the ratio of the Earning from trade(% of GDP) in Marshall Islands in 1999 to that in 2002?
Offer a very short reply. 1.08. What is the ratio of the Earning from trade(% of GDP) in Cabo Verde in 2000 to that in 2001?
Keep it short and to the point. 1.03. What is the ratio of the Earning from trade(% of GDP) in Marshall Islands in 2000 to that in 2001?
Your answer should be very brief. 0.96. What is the ratio of the Earning from trade(% of GDP) of Burkina Faso in 2000 to that in 2002?
Provide a succinct answer. 1.01. What is the ratio of the Earning from trade(% of GDP) in Cabo Verde in 2000 to that in 2002?
Your answer should be very brief. 0.97. What is the ratio of the Earning from trade(% of GDP) in Marshall Islands in 2000 to that in 2002?
Your answer should be very brief. 0.88. What is the ratio of the Earning from trade(% of GDP) of Burkina Faso in 2001 to that in 2002?
Offer a very short reply. 1.02. What is the ratio of the Earning from trade(% of GDP) of Cabo Verde in 2001 to that in 2002?
Keep it short and to the point. 0.94. What is the ratio of the Earning from trade(% of GDP) of Marshall Islands in 2001 to that in 2002?
Offer a terse response. 0.91. What is the difference between the highest and the second highest Earning from trade(% of GDP) of Burkina Faso?
Give a very brief answer. 3.45. What is the difference between the highest and the second highest Earning from trade(% of GDP) in Cabo Verde?
Ensure brevity in your answer.  2.62. What is the difference between the highest and the second highest Earning from trade(% of GDP) in Marshall Islands?
Keep it short and to the point. 1.22. What is the difference between the highest and the lowest Earning from trade(% of GDP) in Burkina Faso?
Make the answer very short. 6.75. What is the difference between the highest and the lowest Earning from trade(% of GDP) of Cabo Verde?
Give a very brief answer. 10.03. What is the difference between the highest and the lowest Earning from trade(% of GDP) in Marshall Islands?
Provide a succinct answer. 24.96. 